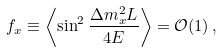Convert formula to latex. <formula><loc_0><loc_0><loc_500><loc_500>f _ { x } \equiv \left < \sin ^ { 2 } \frac { \Delta m ^ { 2 } _ { x } L } { 4 E } \right > = \mathcal { O } ( 1 ) \, ,</formula> 